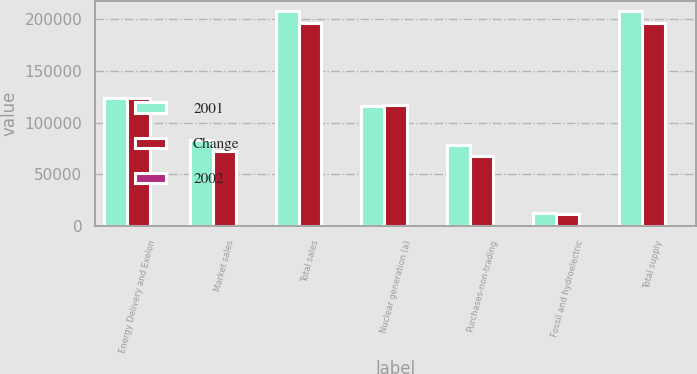Convert chart. <chart><loc_0><loc_0><loc_500><loc_500><stacked_bar_chart><ecel><fcel>Energy Delivery and Exelon<fcel>Market sales<fcel>Total sales<fcel>Nuclear generation (a)<fcel>Purchases-non-trading<fcel>Fossil and hydroelectric<fcel>Total supply<nl><fcel>2001<fcel>123975<fcel>83565<fcel>207540<fcel>115854<fcel>78710<fcel>12976<fcel>207540<nl><fcel>Change<fcel>123793<fcel>72333<fcel>196126<fcel>116839<fcel>67942<fcel>11345<fcel>196126<nl><fcel>2002<fcel>0.1<fcel>15.5<fcel>5.8<fcel>0.8<fcel>15.8<fcel>14.4<fcel>5.8<nl></chart> 